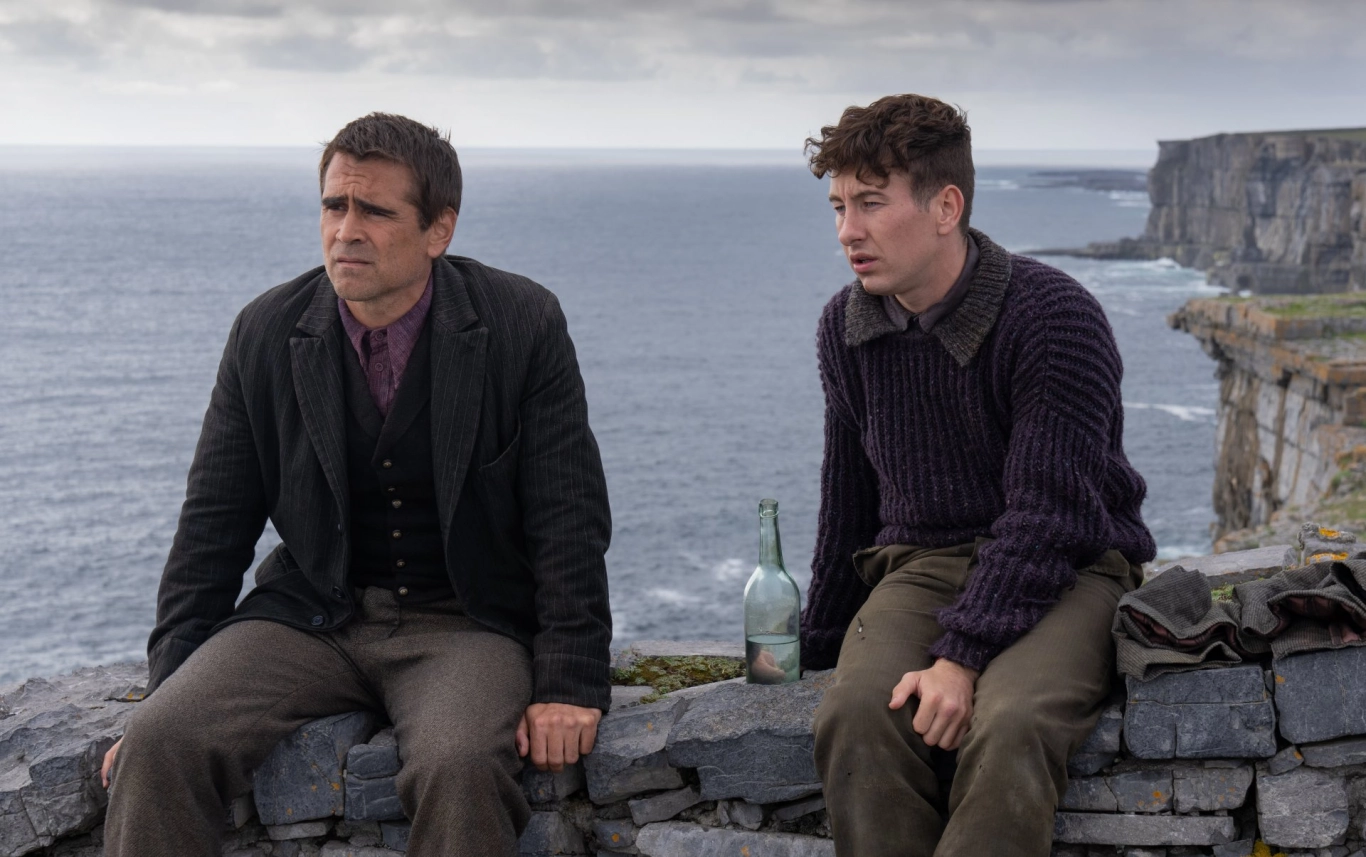If you had to write a poem inspired by this image, how would it go? Upon this rugged, ancient stone,
Two souls sit, both lost, alone.
The ocean whispers tales untold,
Of dreams that shimmer, hearts turned cold.
Their eyes fixed on the distant wave,
Seeking peace, answers, courage brave.
A bottle rests, a silent keeper,
Of stories shared, of laughter deeper.
Beside the cliffs so bold and steep,
Two journeyed hearts their secrets keep. Describe a realistic scenario these two individuals might be in, a short one. Liam and Jack are colleagues who have come to this cliffside during their lunch break while attending a corporate retreat. Both are reflecting on a challenging project that has strained their professional relationship. The serene ocean view provides a quiet space for them to think and maybe, just maybe, find a way to reconcile their differences. Describe another realistic scenario, but a longer one. Liam and Jack, once the best of friends, have found themselves at odds after years of running a business together. They've come to this remote cliffside, a spot they used to visit during their university days, to find some clarity away from the noise of the city. The business, initially a dream project born from their shared passion for adventure, has become a source of tension and conflict. Here, amid the natural beauty and the soothing sounds of the ocean, they sit in silence, each pondering the future. Liam thinks about his desire to expand and innovate, while Jack longs for the simpler days when the joy of exploration was their only goal. With the familiar surroundings as a backdrop, they hope to talk through their differences and perhaps rekindle the old spirit of their friendship. The green bottle between them holds water from an ancient spring nearby, a symbolic gesture from their past adventures. The backpack contains old maps, field notes, and personal mementos, reminding them of the journey they've shared and the paths that have yet to be walked. 